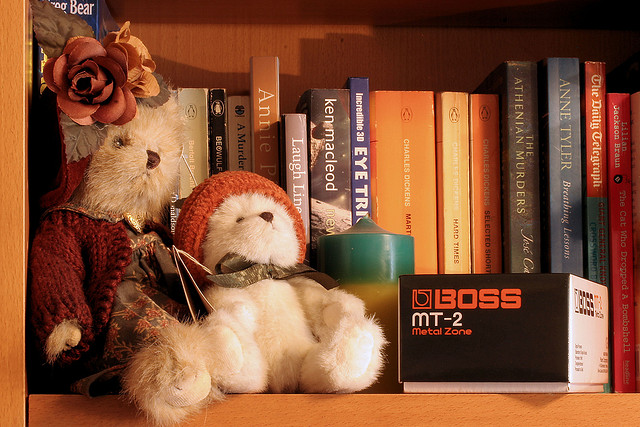Please transcribe the text information in this image. BOSS mT 2 Metal Zone Jose Bombshell Dropped Car Braun Jackson Daily Lessons TYLER ANNE MURDERS THE ATHENIAN MART CHARLES Incredible 30 EYE TRI Kenmacleod Line Laugh Annie Murder Bear 